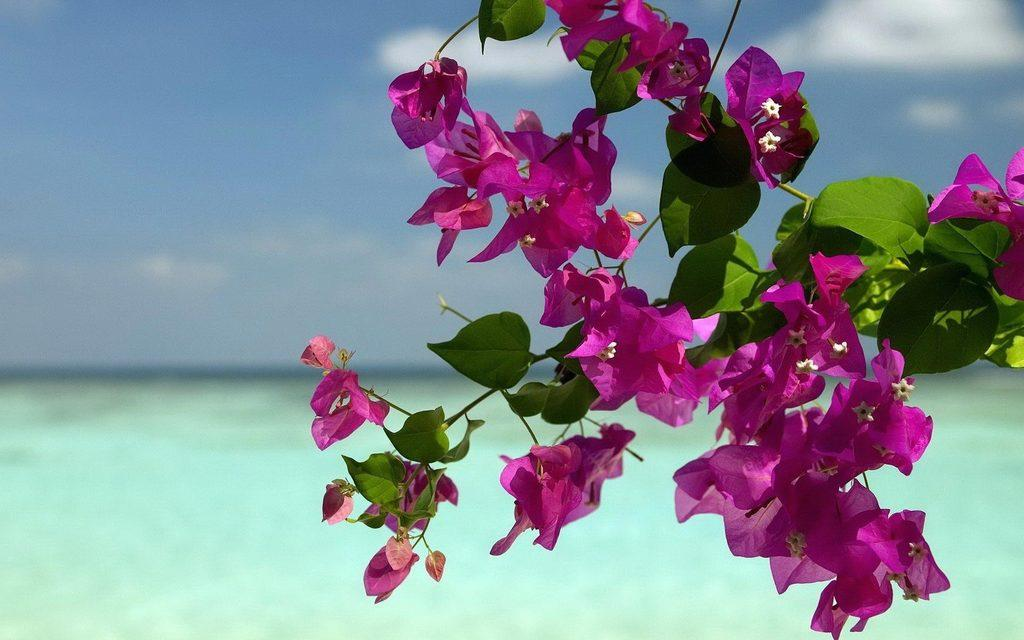What color are the flowers in the image? The flowers in the image are pink. What other parts of the flowers can be seen besides the petals? The flowers have leaves. How are the flowers attached to the plant? The flowers are on a stem. What can be observed about the background of the image? The background is blurred. What type of butter is being used to paint the flowers in the image? There is no butter present in the image, and the flowers are not being painted. 